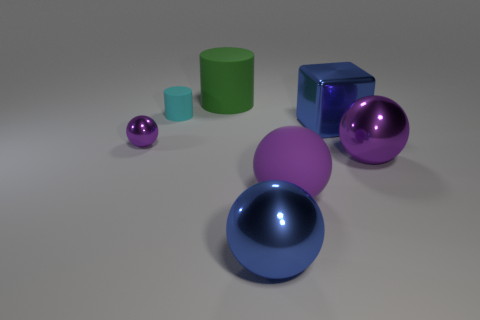There is a purple sphere that is in front of the large purple metallic object; how many purple things are to the right of it?
Give a very brief answer. 1. How many things are either large rubber balls or brown spheres?
Your answer should be compact. 1. Does the purple rubber object have the same shape as the cyan object?
Keep it short and to the point. No. What is the tiny purple ball made of?
Provide a succinct answer. Metal. How many matte things are both on the right side of the small cylinder and behind the large cube?
Ensure brevity in your answer.  1. Does the blue sphere have the same size as the cyan cylinder?
Ensure brevity in your answer.  No. There is a blue thing left of the purple rubber sphere; does it have the same size as the large blue shiny block?
Keep it short and to the point. Yes. There is a large object left of the big blue ball; what is its color?
Offer a terse response. Green. What number of purple things are there?
Offer a very short reply. 3. What is the shape of the small object that is made of the same material as the blue sphere?
Give a very brief answer. Sphere. 